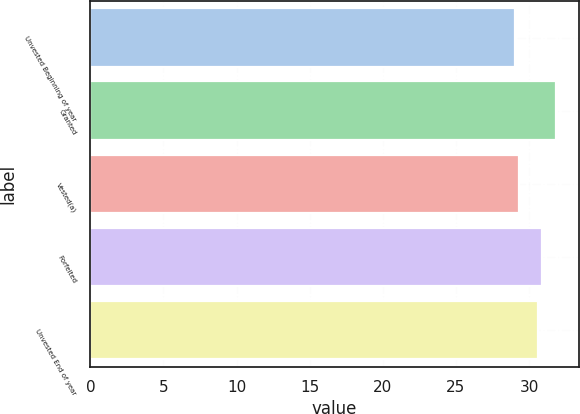Convert chart. <chart><loc_0><loc_0><loc_500><loc_500><bar_chart><fcel>Unvested Beginning of year<fcel>Granted<fcel>Vested(a)<fcel>Forfeited<fcel>Unvested End of year<nl><fcel>29.04<fcel>31.82<fcel>29.32<fcel>30.91<fcel>30.63<nl></chart> 